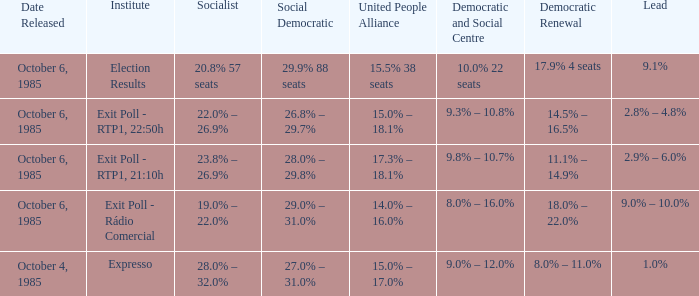Which organizations provided the democratic revival 1 Exit Poll - Rádio Comercial. 